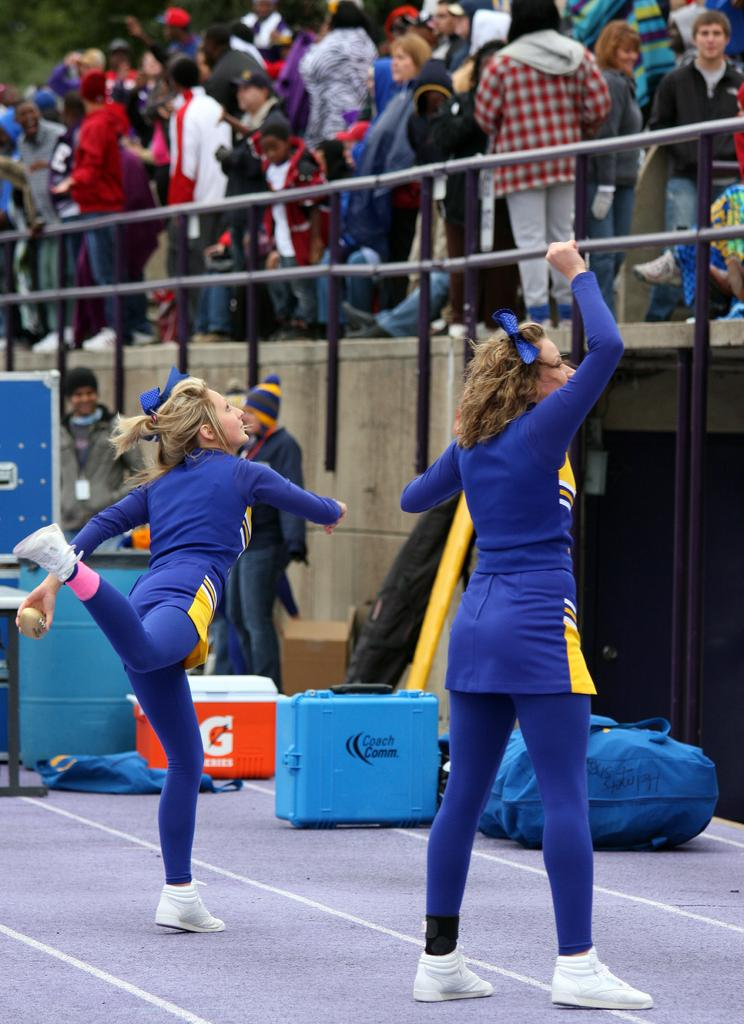What is the main subject of the image? There is a person standing in the center of the image. What is the person standing on? The person is standing on the ground. What can be seen in the background of the image? There is a crowd, fencing, and a wall in the background of the image. What type of furniture is being adjusted by the person in the image? There is no furniture present in the image, and the person is not adjusting anything. 